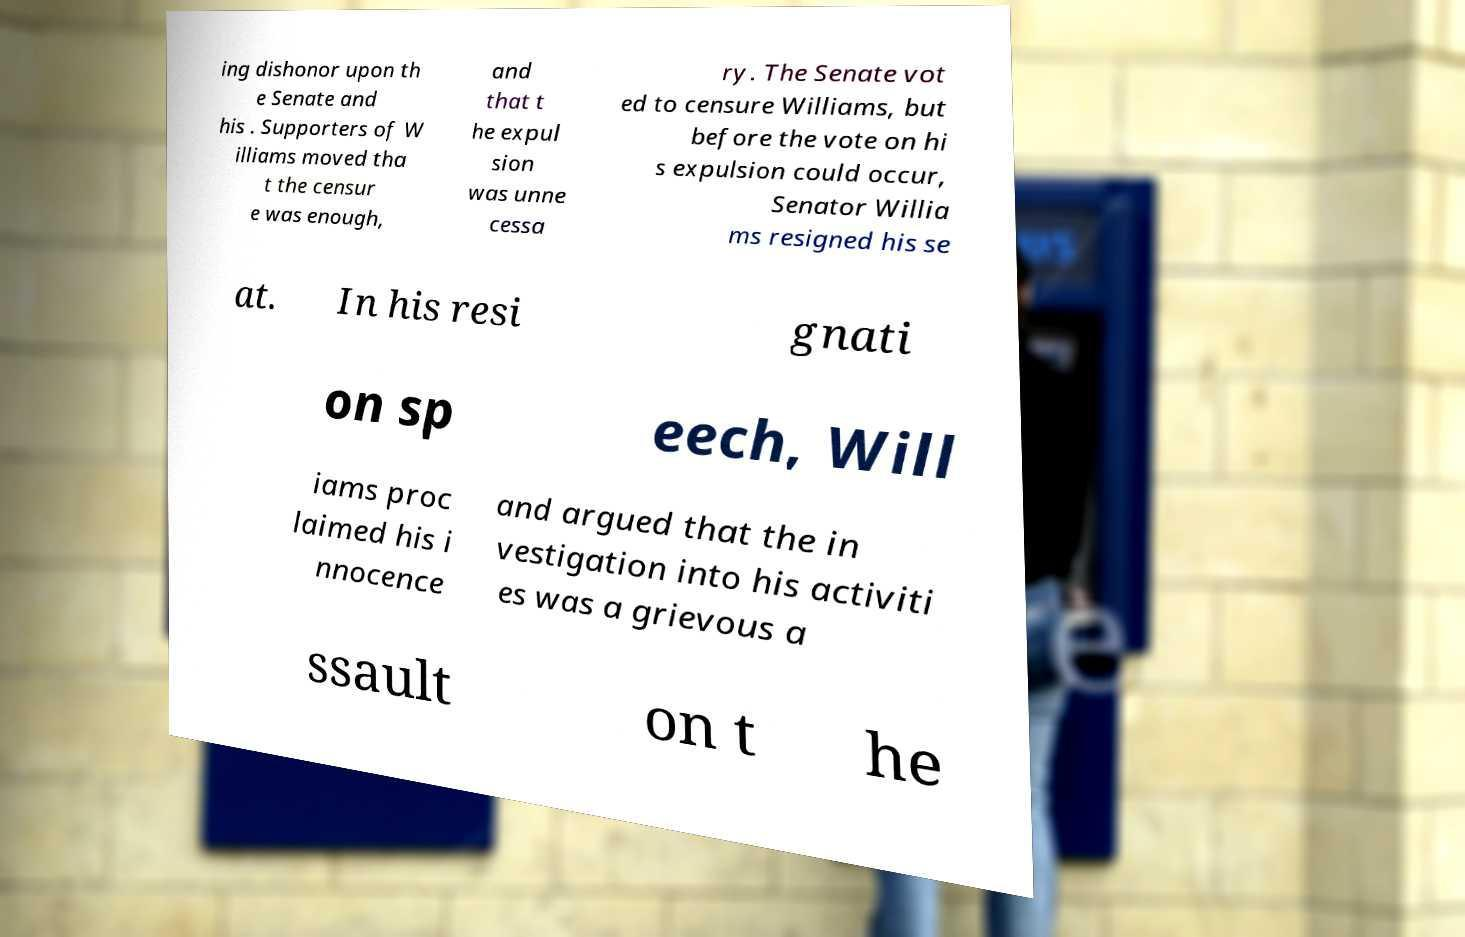Could you assist in decoding the text presented in this image and type it out clearly? ing dishonor upon th e Senate and his . Supporters of W illiams moved tha t the censur e was enough, and that t he expul sion was unne cessa ry. The Senate vot ed to censure Williams, but before the vote on hi s expulsion could occur, Senator Willia ms resigned his se at. In his resi gnati on sp eech, Will iams proc laimed his i nnocence and argued that the in vestigation into his activiti es was a grievous a ssault on t he 